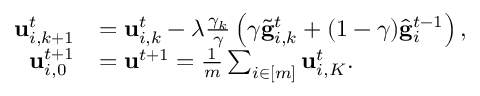<formula> <loc_0><loc_0><loc_500><loc_500>\begin{array} { r l } { u _ { i , k + 1 } ^ { t } } & { = u _ { i , k } ^ { t } - \lambda \frac { \gamma _ { k } } { \gamma } \left ( \gamma \tilde { g } _ { i , k } ^ { t } + ( 1 - \gamma ) \hat { g } _ { i } ^ { t - 1 } \right ) , } \\ { u _ { i , 0 } ^ { t + 1 } } & { = u ^ { t + 1 } = \frac { 1 } { m } \sum _ { i \in [ m ] } u _ { i , K } ^ { t } . } \end{array}</formula> 